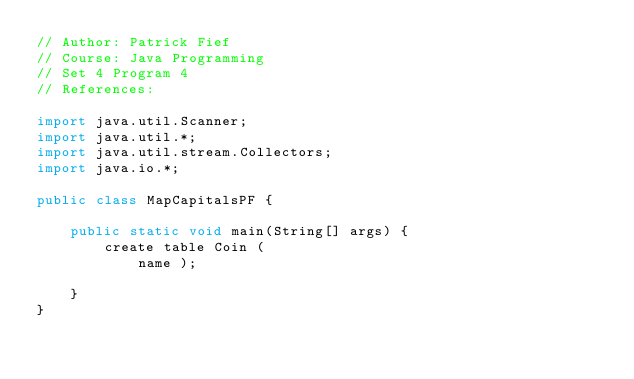<code> <loc_0><loc_0><loc_500><loc_500><_Java_>// Author: Patrick Fief
// Course: Java Programming
// Set 4 Program 4
// References: 

import java.util.Scanner;
import java.util.*;
import java.util.stream.Collectors;
import java.io.*;

public class MapCapitalsPF {
    
    public static void main(String[] args) {
        create table Coin (
            name );
        
    }
}</code> 